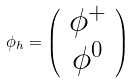<formula> <loc_0><loc_0><loc_500><loc_500>\phi _ { h } = \left ( \begin{array} { c } { { \phi ^ { + } } } \\ { { \phi ^ { 0 } } } \end{array} \right )</formula> 